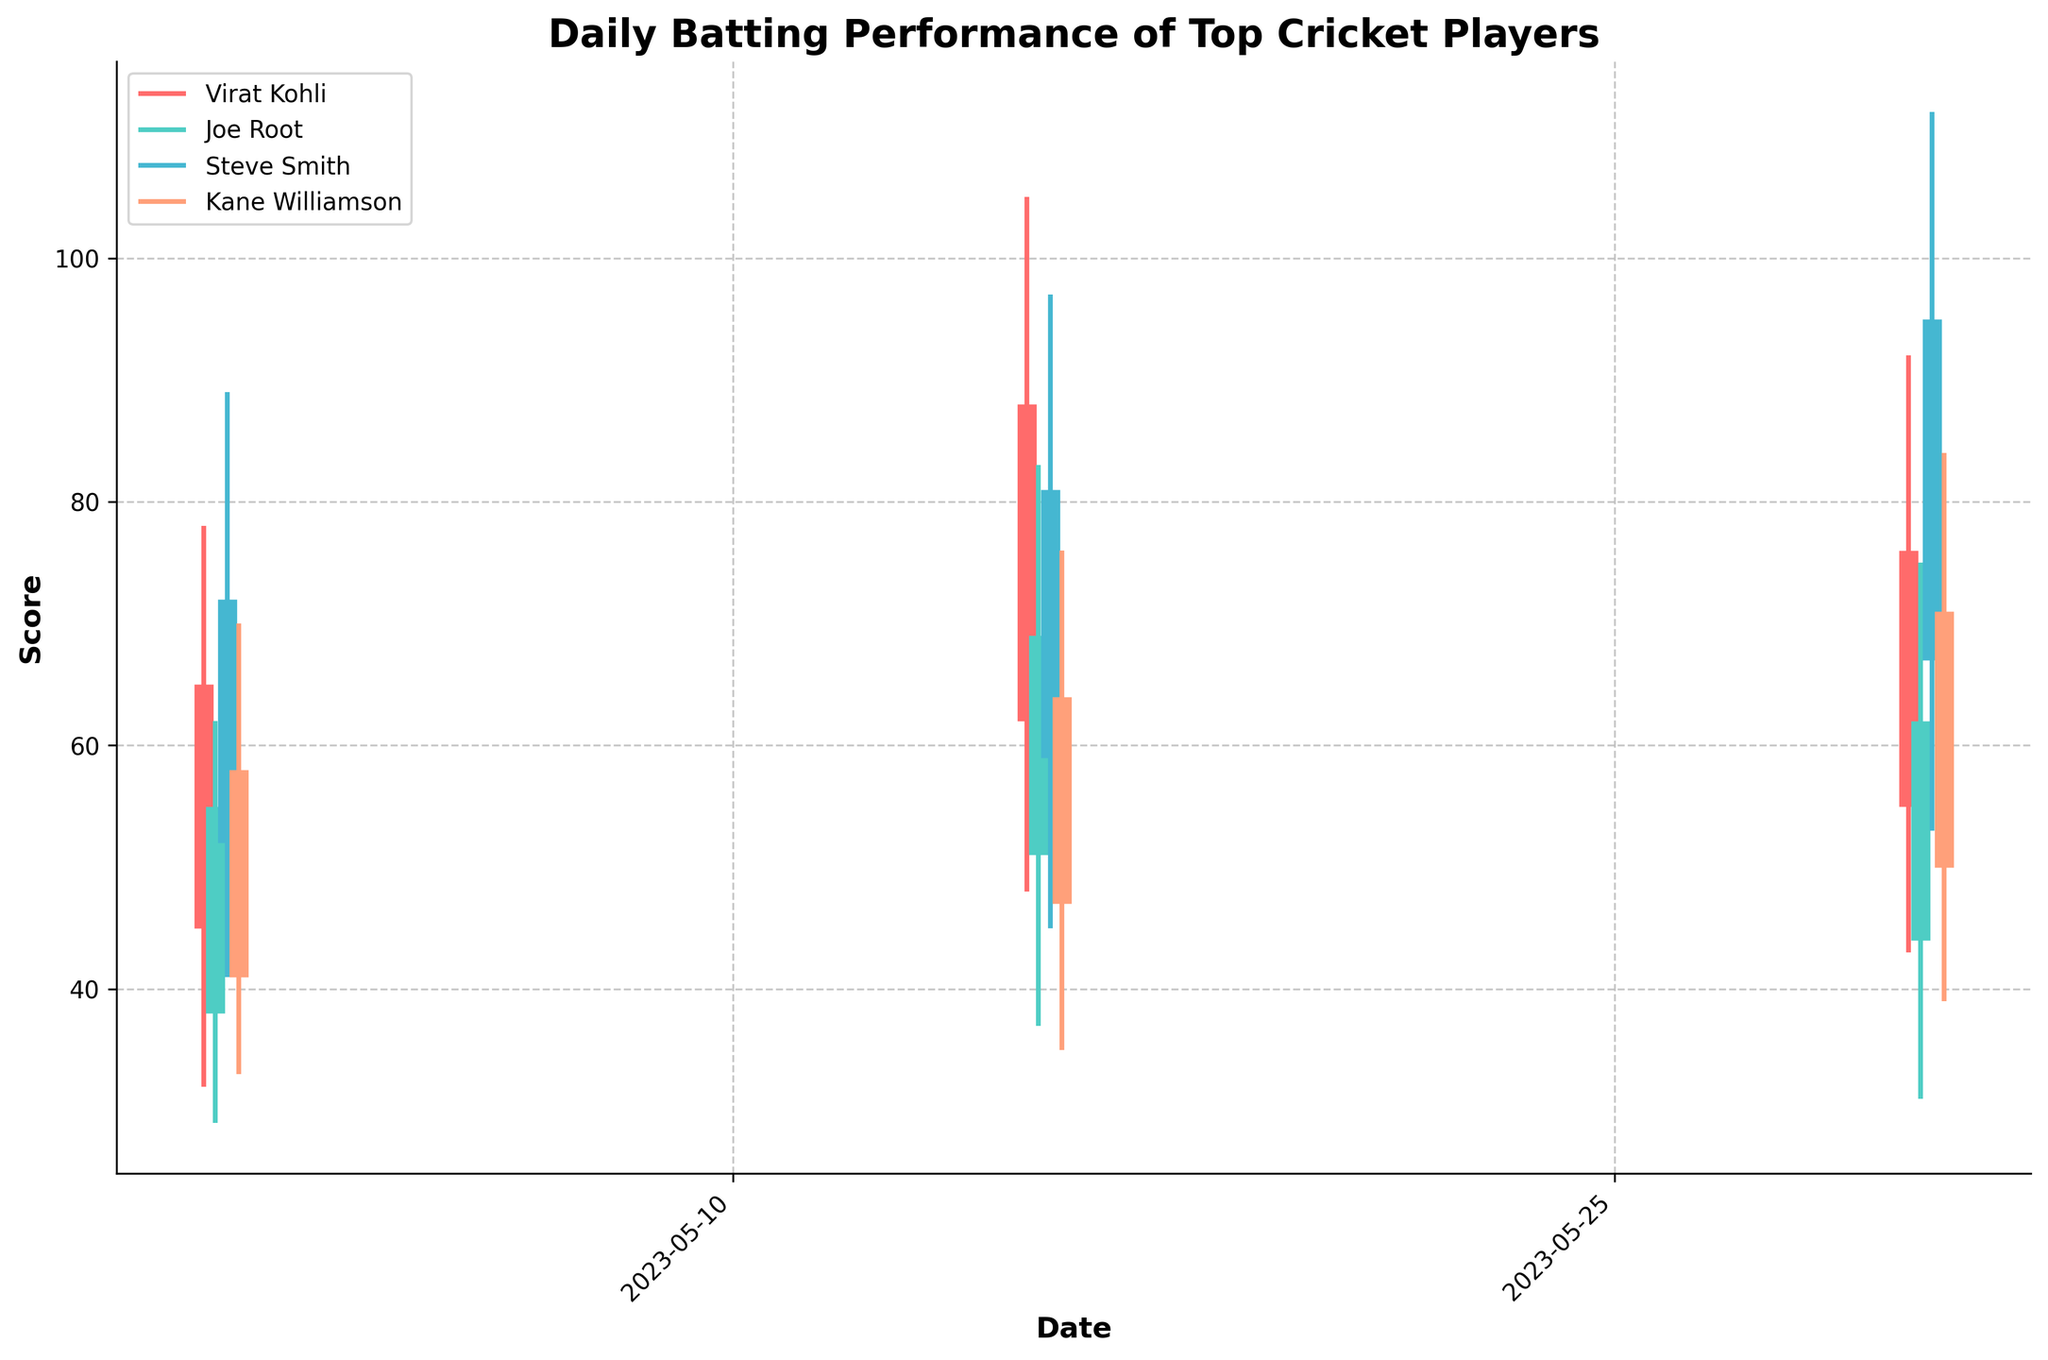What's the title of the figure? The title of the figure is displayed at the top and provides an overview of what the figure represents. By looking at the top of the plot, we can see the specified title.
Answer: Daily Batting Performance of Top Cricket Players Which players are represented in the figure? The figure uses different colors to represent different players. By looking at the legend on the plot, we can see the names of all the players represented.
Answer: Virat Kohli, Joe Root, Steve Smith, Kane Williamson What are the dates covered in the figure? The x-axis of the plot displays the dates. By observing the axis, we can identify the specific dates included in the chart.
Answer: May 1, 2023, May 15, 2023, May 30, 2023 Which player had the highest score on May 15th? By examining the individual player lines and their high points on May 15th, we can identify the player with the highest score. Steve Smith's line reaches the highest point on this date.
Answer: Steve Smith On which date did Virat Kohli have his highest close score? To find this, we need to look at the close scores for each instance of Virat Kohli. The highest close score among the dates will indicate the answer.
Answer: May 15, 2023 Which player showed the most improvement in their close score from May 1st to May 15th? We need to compare the close scores of each player on May 1st and May 15th. The player with the largest positive difference in close scores between these dates shows the most improvement. For Virat Kohli: 88 - 65 = 23, for Joe Root: 69 - 55 = 14, for Steve Smith: 81 - 72 = 9, for Kane Williamson: 64 - 58 = 6. Therefore, Virat Kohli showed the most improvement.
Answer: Virat Kohli Who had a higher open score on May 15th, Joe Root or Steve Smith? By examining the open scores of Joe Root and Steve Smith on May 15th, we can determine who had the higher value. Joe Root's open score is 51, while Steve Smith's is 59.
Answer: Steve Smith On which date did Kane Williamson have his lowest point, and what was the score? By looking at the low scores for Kane Williamson on each date, we can identify the lowest point and the corresponding date. On May 1st, his low score was 33, which is the lowest.
Answer: May 1, 2023 at 33 What is the difference between the highest high score and the lowest low score for Steve Smith on May 30th? To find the difference, we need to subtract the lowest low score from the highest high score for Steve Smith on May 30th. The high score is 112 and the low score is 53. The difference is 112 - 53 = 59.
Answer: 59 Which player had the narrowest range of scores on May 30th? The range is determined by subtracting the low score from the high score for each player on May 30th. Virat Kohli: 92 - 43 = 49, Joe Root: 75 - 31 = 44, Steve Smith: 112 - 53 = 59, Kane Williamson: 84 - 39 = 45. The narrowest range is for Joe Root.
Answer: Joe Root 